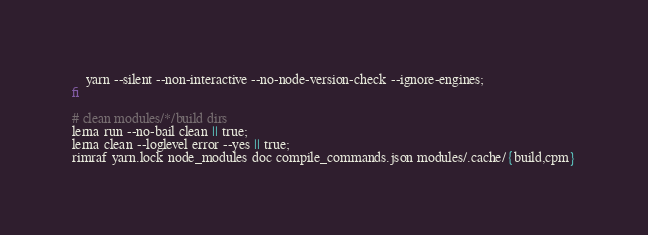<code> <loc_0><loc_0><loc_500><loc_500><_Bash_>    yarn --silent --non-interactive --no-node-version-check --ignore-engines;
fi

# clean modules/*/build dirs
lerna run --no-bail clean || true;
lerna clean --loglevel error --yes || true;
rimraf yarn.lock node_modules doc compile_commands.json modules/.cache/{build,cpm}
</code> 